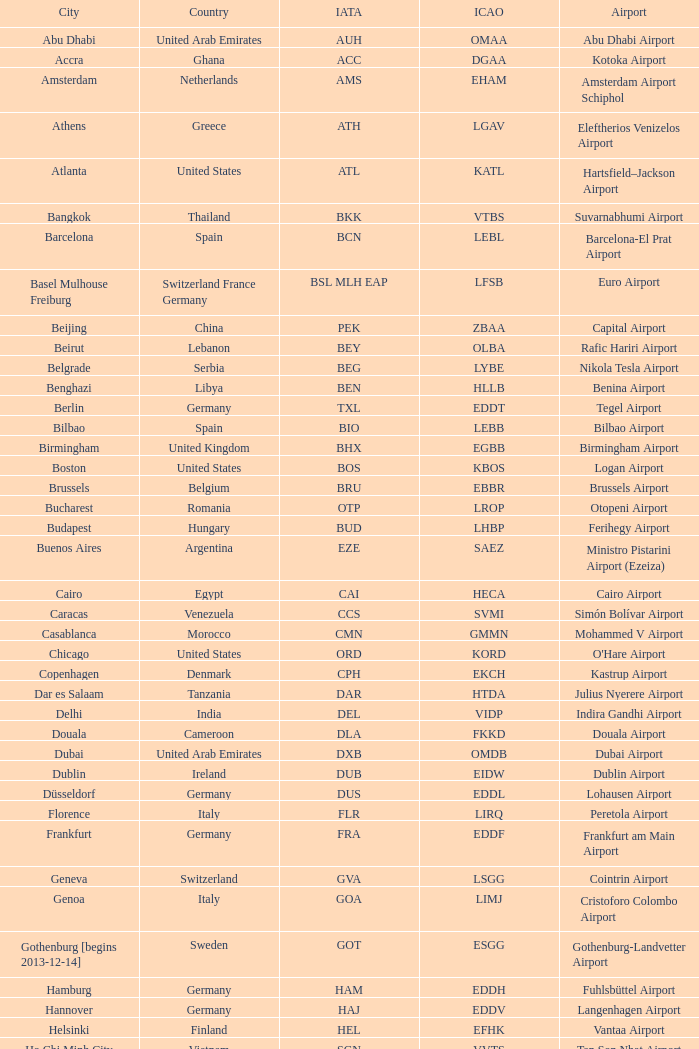In which city is fuhlsbüttel airport located? Hamburg. 